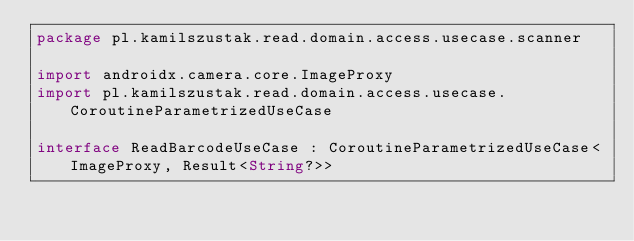Convert code to text. <code><loc_0><loc_0><loc_500><loc_500><_Kotlin_>package pl.kamilszustak.read.domain.access.usecase.scanner

import androidx.camera.core.ImageProxy
import pl.kamilszustak.read.domain.access.usecase.CoroutineParametrizedUseCase

interface ReadBarcodeUseCase : CoroutineParametrizedUseCase<ImageProxy, Result<String?>></code> 